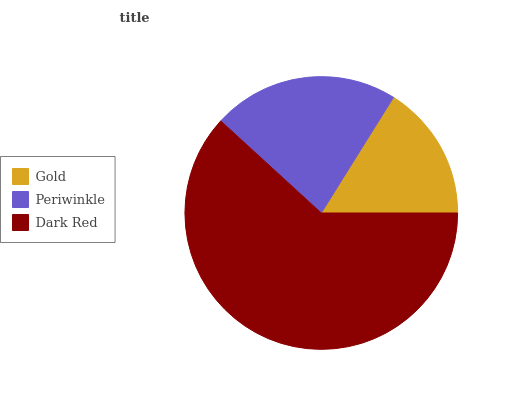Is Gold the minimum?
Answer yes or no. Yes. Is Dark Red the maximum?
Answer yes or no. Yes. Is Periwinkle the minimum?
Answer yes or no. No. Is Periwinkle the maximum?
Answer yes or no. No. Is Periwinkle greater than Gold?
Answer yes or no. Yes. Is Gold less than Periwinkle?
Answer yes or no. Yes. Is Gold greater than Periwinkle?
Answer yes or no. No. Is Periwinkle less than Gold?
Answer yes or no. No. Is Periwinkle the high median?
Answer yes or no. Yes. Is Periwinkle the low median?
Answer yes or no. Yes. Is Gold the high median?
Answer yes or no. No. Is Gold the low median?
Answer yes or no. No. 